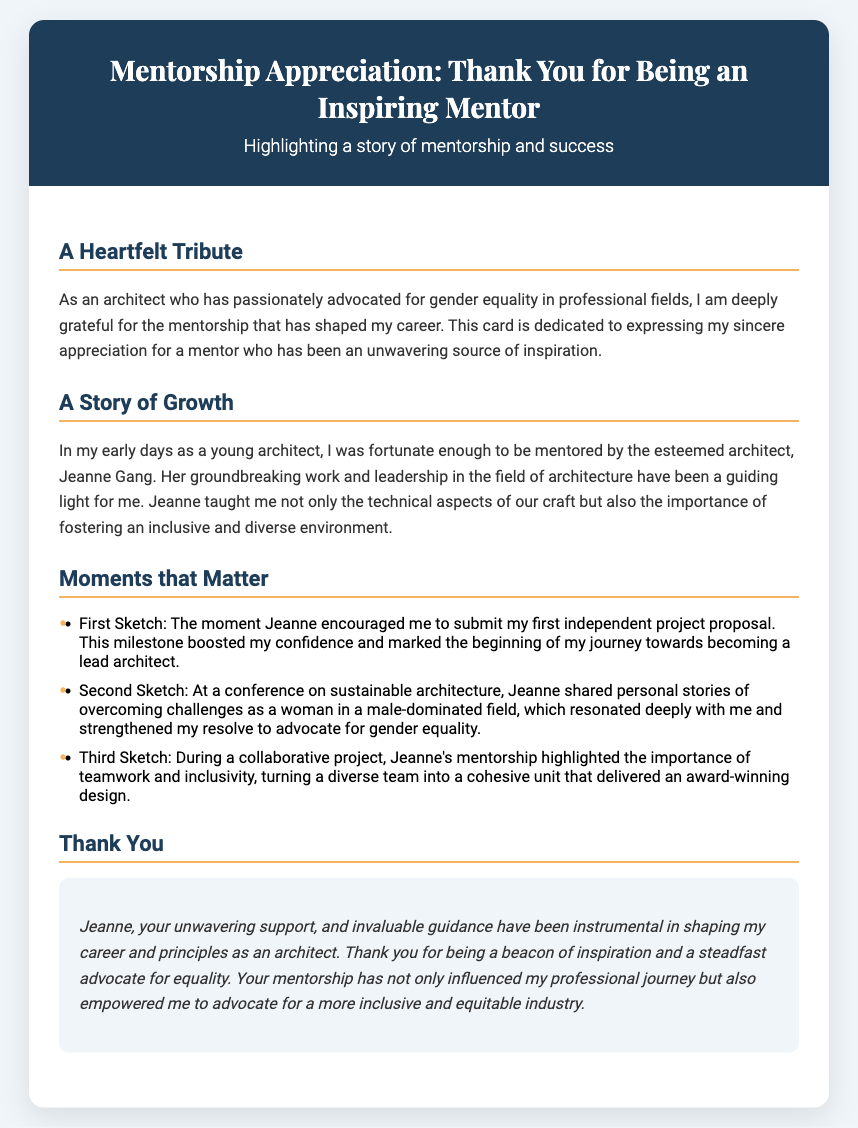What is the title of the card? The title of the card is displayed prominently at the top and reads "Mentorship Appreciation: Thank You for Being an Inspiring Mentor."
Answer: Mentorship Appreciation: Thank You for Being an Inspiring Mentor Who is the mentor mentioned in the card? The document highlights the mentor as Jeanne Gang, an esteemed architect known for her groundbreaking work and leadership.
Answer: Jeanne Gang What profession does the author of the card identify with? The card communicates that the author is an architect and emphasizes their advocacy for gender equality in the field.
Answer: Architect What did Jeanne encourage the author to submit? The card references a significant moment where Jeanne encouraged the author to submit their first independent project proposal.
Answer: First independent project proposal Which theme is emphasized during the conference mentioned? The section speaks of a conference on sustainable architecture where Jeanne discussed overcoming challenges related to gender in a male-dominated field.
Answer: Overcoming challenges What kind of team did Jeanne's mentorship help to create? The content describes how Jeanne's mentorship transformed a diverse team into a cohesive unit that delivered an award-winning design.
Answer: Cohesive unit How is Jeanne's support described in the "Thank You" section? The document states that Jeanne's support is described as unwavering and invaluable, significantly impacting the author's career.
Answer: Unwavering and invaluable In which area has the author passionately advocated? The author expresses a deep commitment to advocating for gender equality in professional fields, particularly in architecture.
Answer: Gender equality 